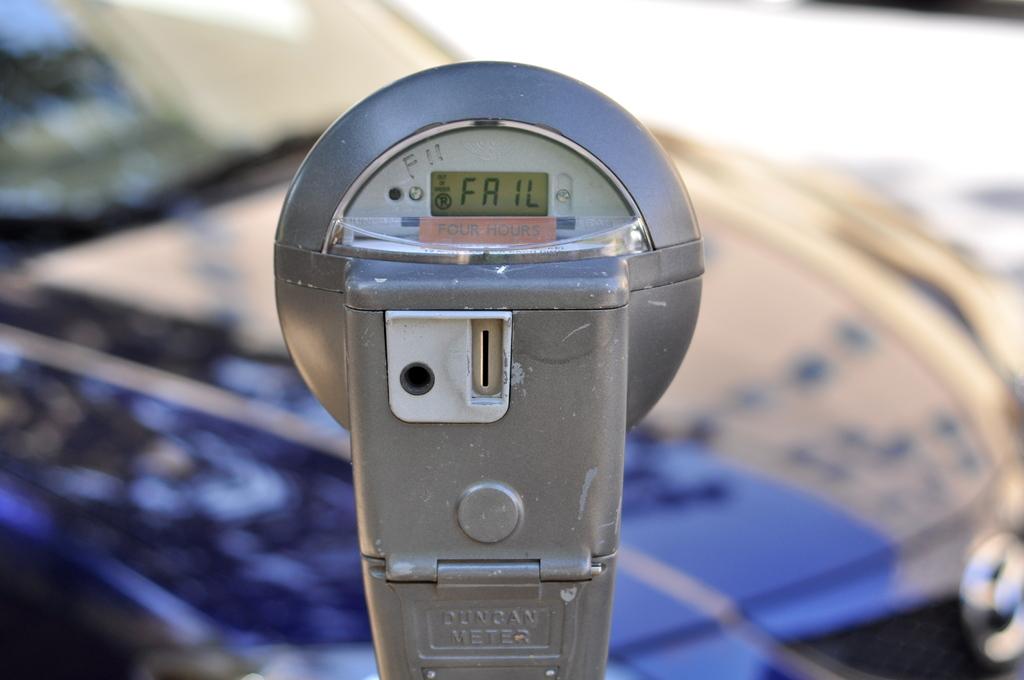What is written in the meter?
Make the answer very short. Fail. What is written in white above the meter message to the left?
Your answer should be very brief. F11. 